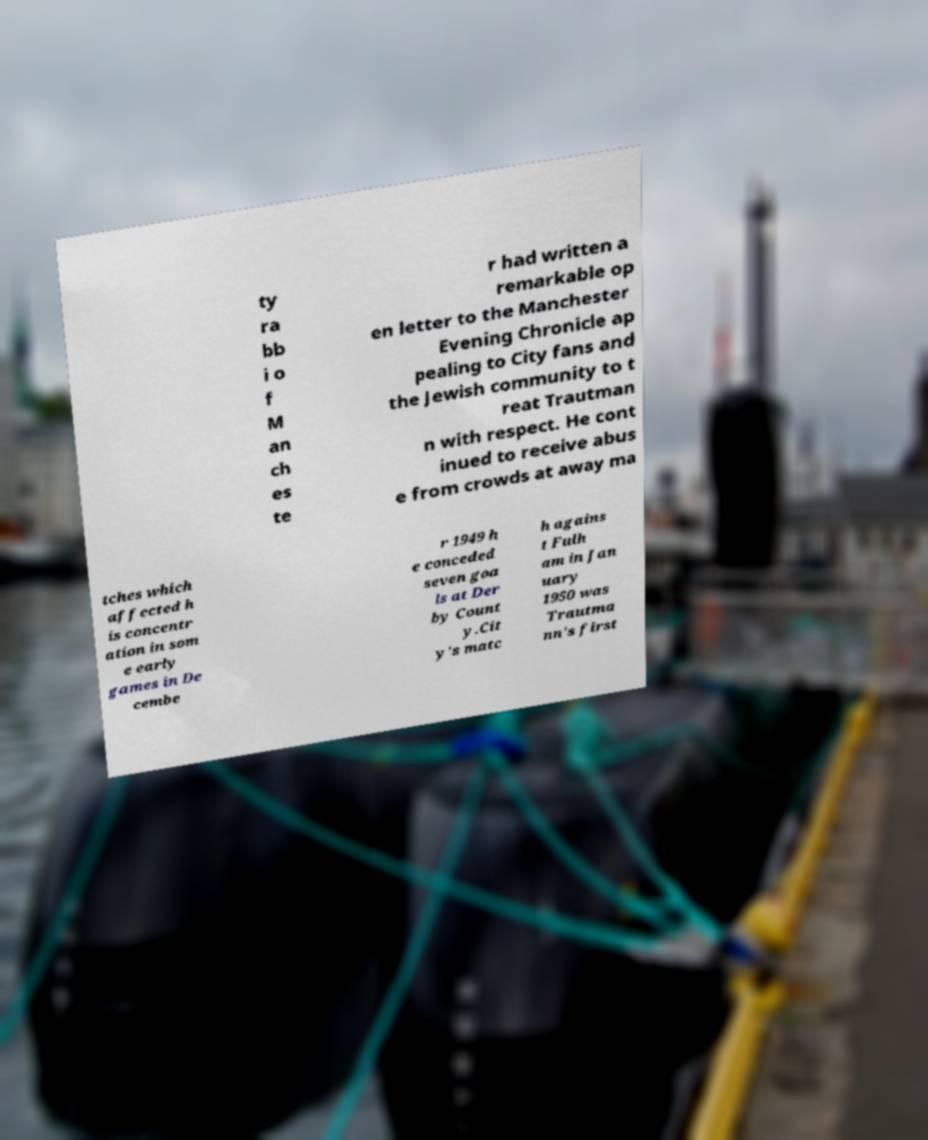Please read and relay the text visible in this image. What does it say? ty ra bb i o f M an ch es te r had written a remarkable op en letter to the Manchester Evening Chronicle ap pealing to City fans and the Jewish community to t reat Trautman n with respect. He cont inued to receive abus e from crowds at away ma tches which affected h is concentr ation in som e early games in De cembe r 1949 h e conceded seven goa ls at Der by Count y.Cit y's matc h agains t Fulh am in Jan uary 1950 was Trautma nn's first 